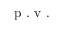<formula> <loc_0><loc_0><loc_500><loc_500>p . v .</formula> 